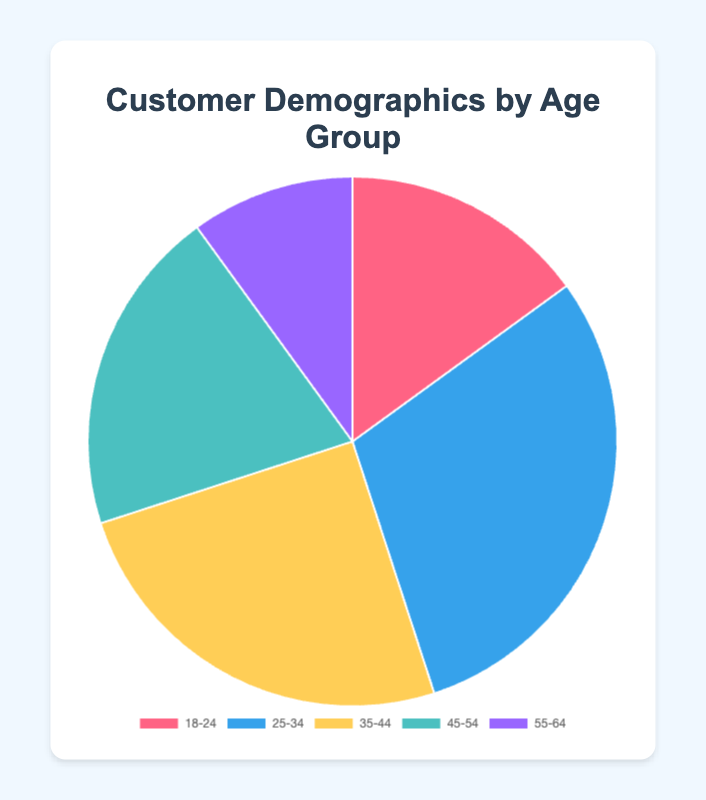Which age group has the highest percentage? The 25-34 age group has the highest percentage, which is 30%.
Answer: 25-34 Which age group has the lowest percentage? The 55-64 age group has the lowest percentage, which is 10%.
Answer: 55-64 What is the total percentage of customers aged 35-44 and 45-54? The percentage of customers aged 35-44 is 25% and 45-54 is 20%. Adding them together, 25% + 20% = 45%.
Answer: 45% How does the percentage of the 18-24 age group compare to the 55-64 age group? The 18-24 age group has a percentage of 15%, while the 55-64 age group has 10%. Thus, 15% is greater than 10%.
Answer: Greater What is the average percentage of customers across all age groups? To calculate the average percentage, sum up all the percentages and divide by the number of age groups. (15% + 30% + 25% + 20% + 10%) / 5 = 100% / 5 = 20%.
Answer: 20% What is the ratio of the percentage of customers aged 25-34 to those aged 45-54? The percentage of customers aged 25-34 is 30%, and for those aged 45-54, it is 20%. The ratio is 30% / 20% = 1.5.
Answer: 1.5 Which age group is represented by the yellow color in the pie chart? The yellow color represents the 35-44 age group on the pie chart.
Answer: 35-44 Combine the percentage of the youngest and oldest age groups you see in the chart. The youngest age group is 18-24 with 15%, and the oldest age group is 55-64 with 10%. Adding them together, 15% + 10% = 25%.
Answer: 25% What is the difference between the percentages of the 25-34 and 35-44 age groups? The 25-34 age group has 30%, and the 35-44 age group has 25%. The difference is 30% - 25% = 5%.
Answer: 5% 